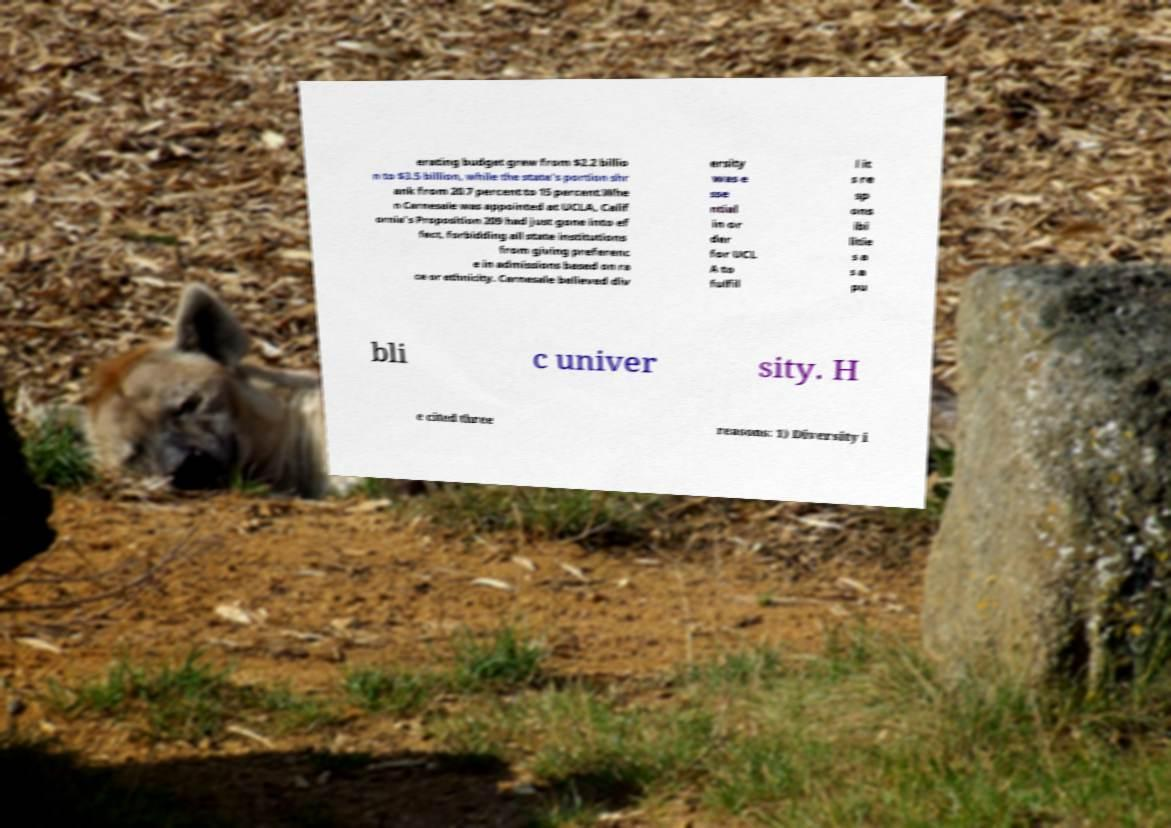Could you assist in decoding the text presented in this image and type it out clearly? erating budget grew from $2.2 billio n to $3.5 billion, while the state's portion shr ank from 20.7 percent to 15 percent.Whe n Carnesale was appointed at UCLA, Calif ornia's Proposition 209 had just gone into ef fect, forbidding all state institutions from giving preferenc e in admissions based on ra ce or ethnicity. Carnesale believed div ersity was e sse ntial in or der for UCL A to fulfil l it s re sp ons ibi litie s a s a pu bli c univer sity. H e cited three reasons: 1) Diversity i 